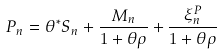Convert formula to latex. <formula><loc_0><loc_0><loc_500><loc_500>P _ { n } = \theta ^ { * } S _ { n } + \frac { M _ { n } } { 1 + \theta \rho } + \frac { \xi _ { n } ^ { P } } { 1 + \theta \rho }</formula> 